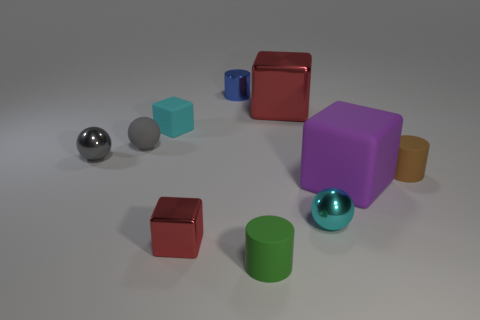Can you tell me if there's any pattern in the placement of the blocks and spheres? At first glance, the placement of the blocks and spheres appears random, but upon closer inspection, you might notice a slight gradation in sizes and an alternating pattern of shapes, giving a subtle rhythm to their arrangement. 